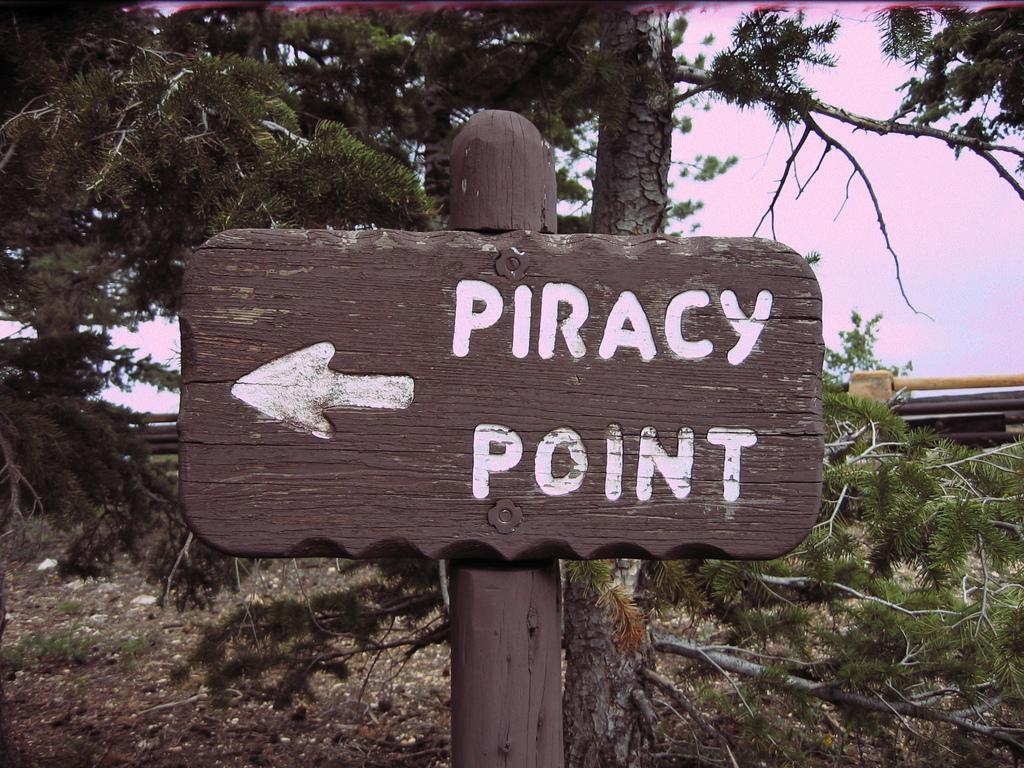What is the main object in the image? There is a wooden pole in the image. What is written on the wooden pole? There is text written on the wooden pole. What can be seen in the background of the image? There are trees and the sky visible in the background of the image. How many feathers are on the table in the image? There is no table or feathers present in the image. What type of event is taking place in the image? There is no event depicted in the image; it only shows a wooden pole with text and a background of trees and the sky. 